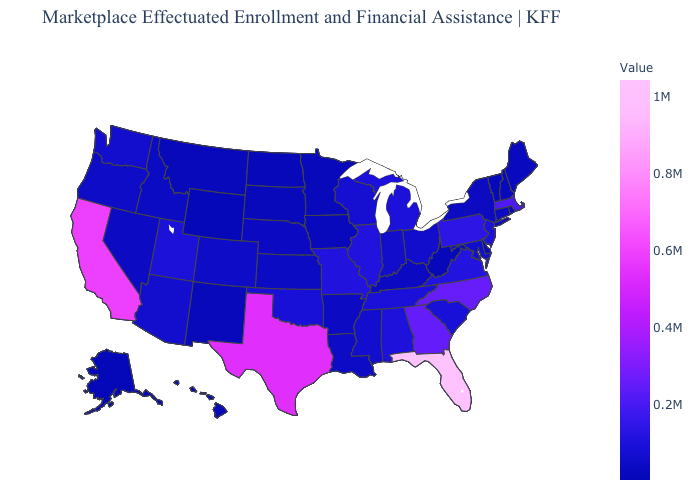Which states have the lowest value in the USA?
Answer briefly. Alaska. Does Montana have the highest value in the USA?
Keep it brief. No. Which states have the highest value in the USA?
Give a very brief answer. Florida. Does Alabama have the lowest value in the South?
Give a very brief answer. No. 